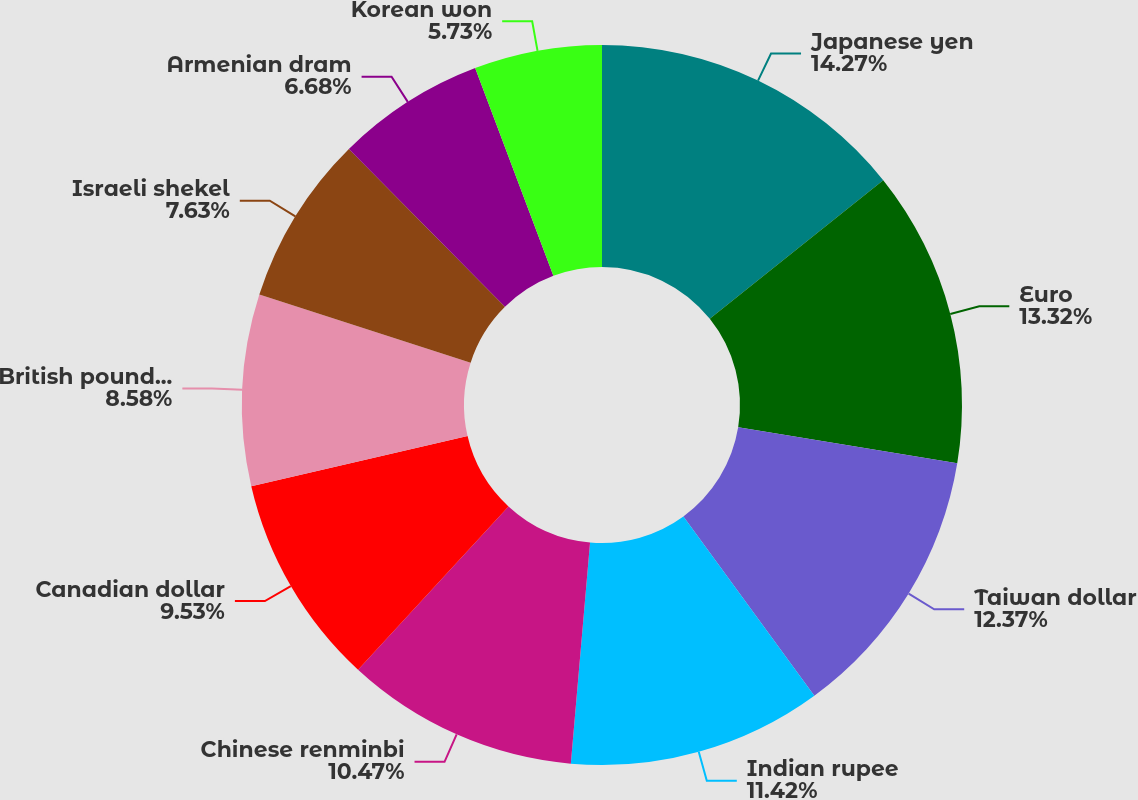Convert chart. <chart><loc_0><loc_0><loc_500><loc_500><pie_chart><fcel>Japanese yen<fcel>Euro<fcel>Taiwan dollar<fcel>Indian rupee<fcel>Chinese renminbi<fcel>Canadian dollar<fcel>British pound sterling<fcel>Israeli shekel<fcel>Armenian dram<fcel>Korean won<nl><fcel>14.27%<fcel>13.32%<fcel>12.37%<fcel>11.42%<fcel>10.47%<fcel>9.53%<fcel>8.58%<fcel>7.63%<fcel>6.68%<fcel>5.73%<nl></chart> 